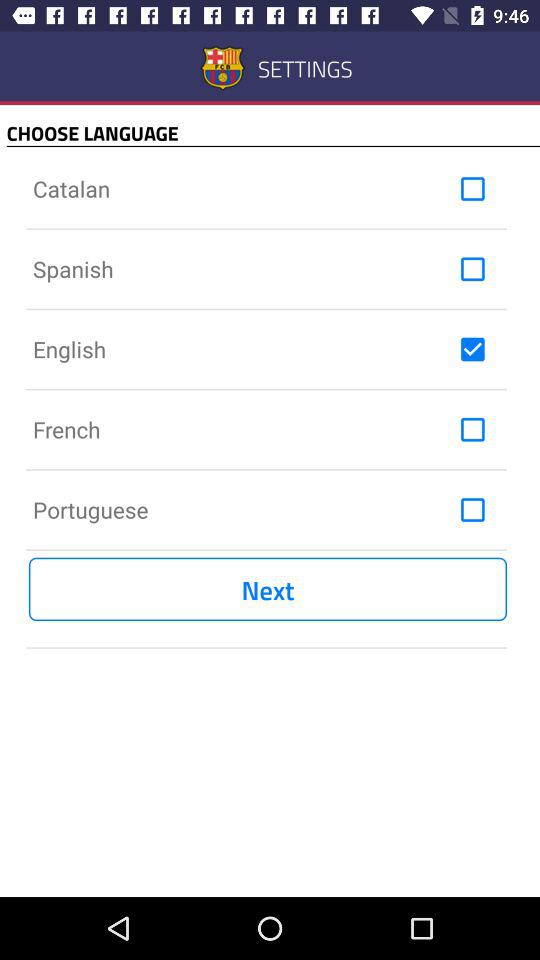What is the selected language? The selected language is English. 